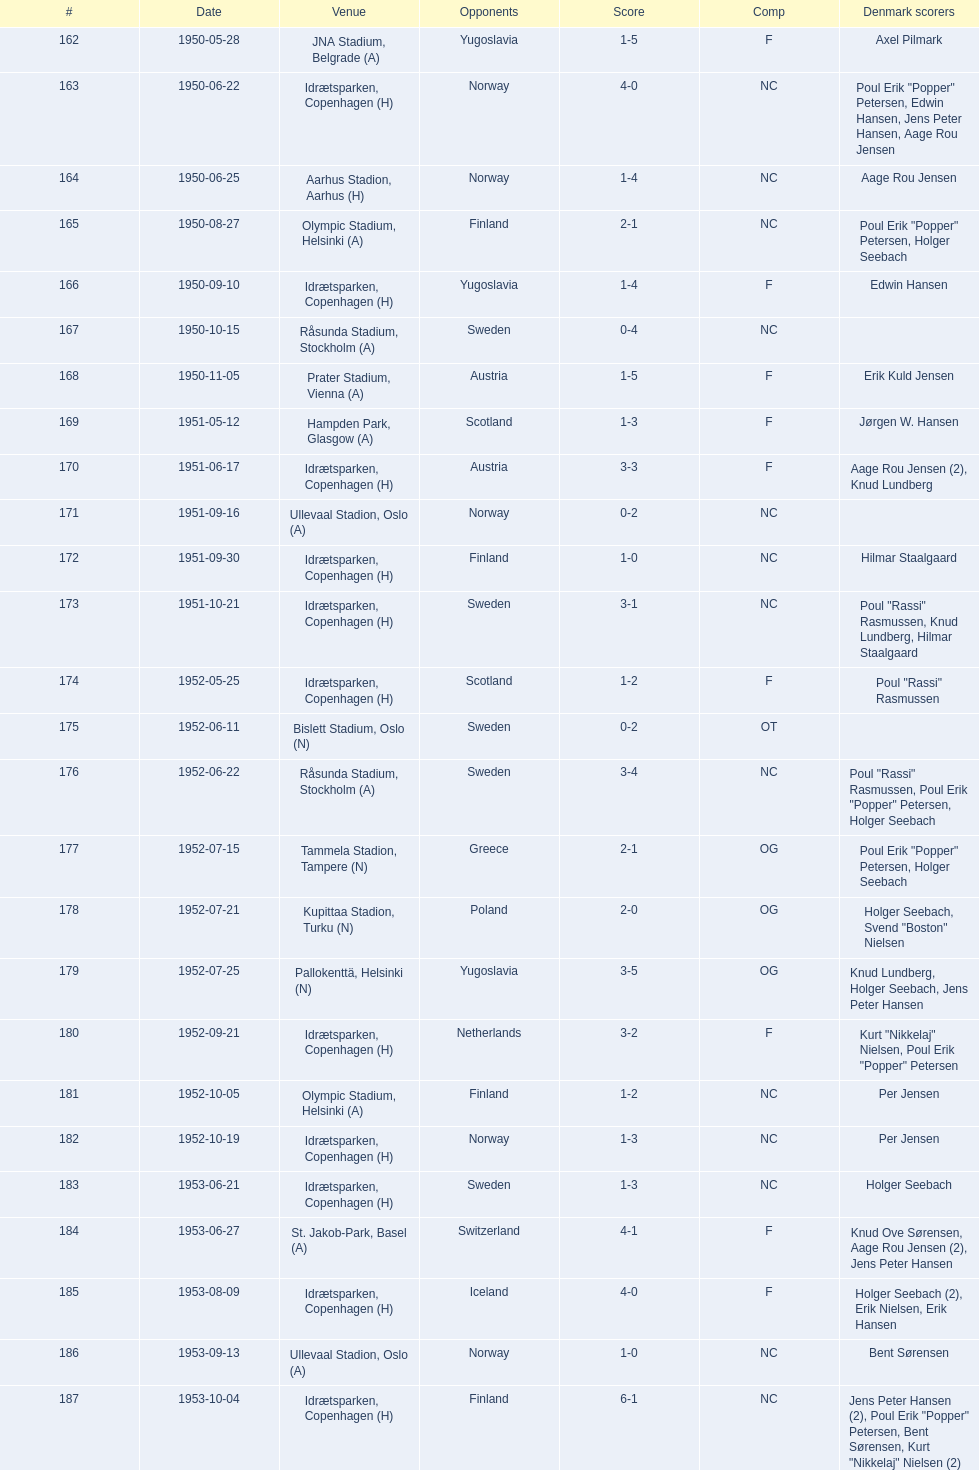Can you identify the venue located immediately below jna stadium, belgrade (a)? Idrætsparken, Copenhagen (H). 